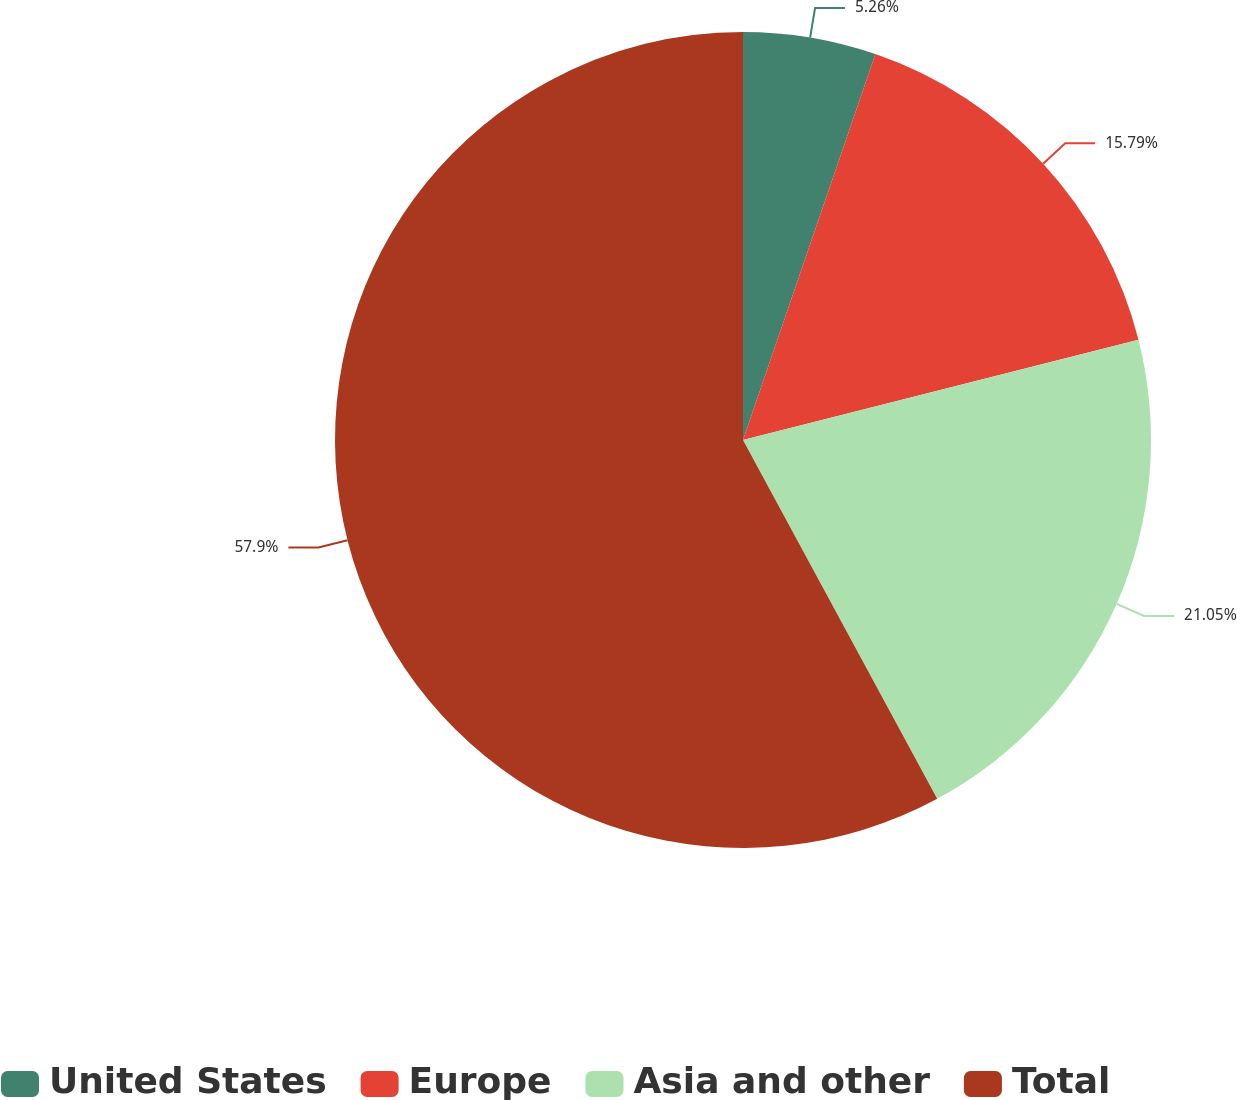Convert chart. <chart><loc_0><loc_0><loc_500><loc_500><pie_chart><fcel>United States<fcel>Europe<fcel>Asia and other<fcel>Total<nl><fcel>5.26%<fcel>15.79%<fcel>21.05%<fcel>57.89%<nl></chart> 